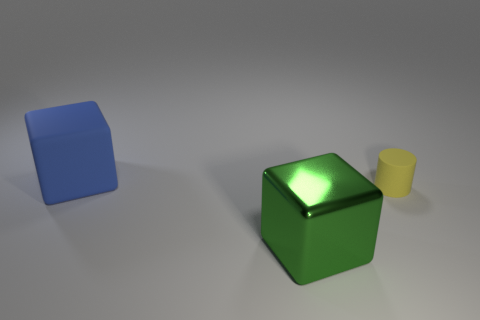Add 2 big yellow cylinders. How many objects exist? 5 Subtract all brown cubes. Subtract all brown cylinders. How many cubes are left? 2 Subtract all cubes. How many objects are left? 1 Add 2 cyan rubber things. How many cyan rubber things exist? 2 Subtract 0 purple spheres. How many objects are left? 3 Subtract all purple matte objects. Subtract all yellow matte cylinders. How many objects are left? 2 Add 3 big blue matte cubes. How many big blue matte cubes are left? 4 